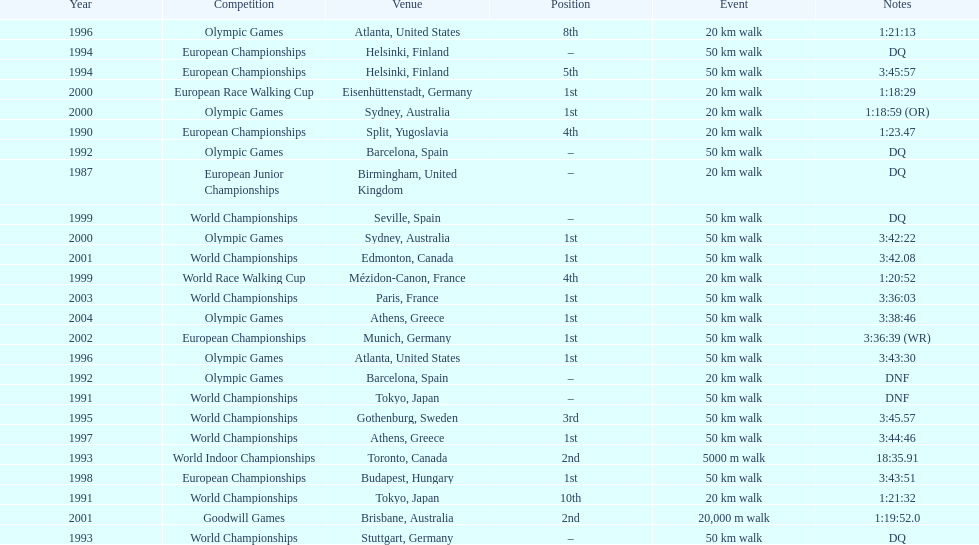How many events were at least 50 km? 17. 